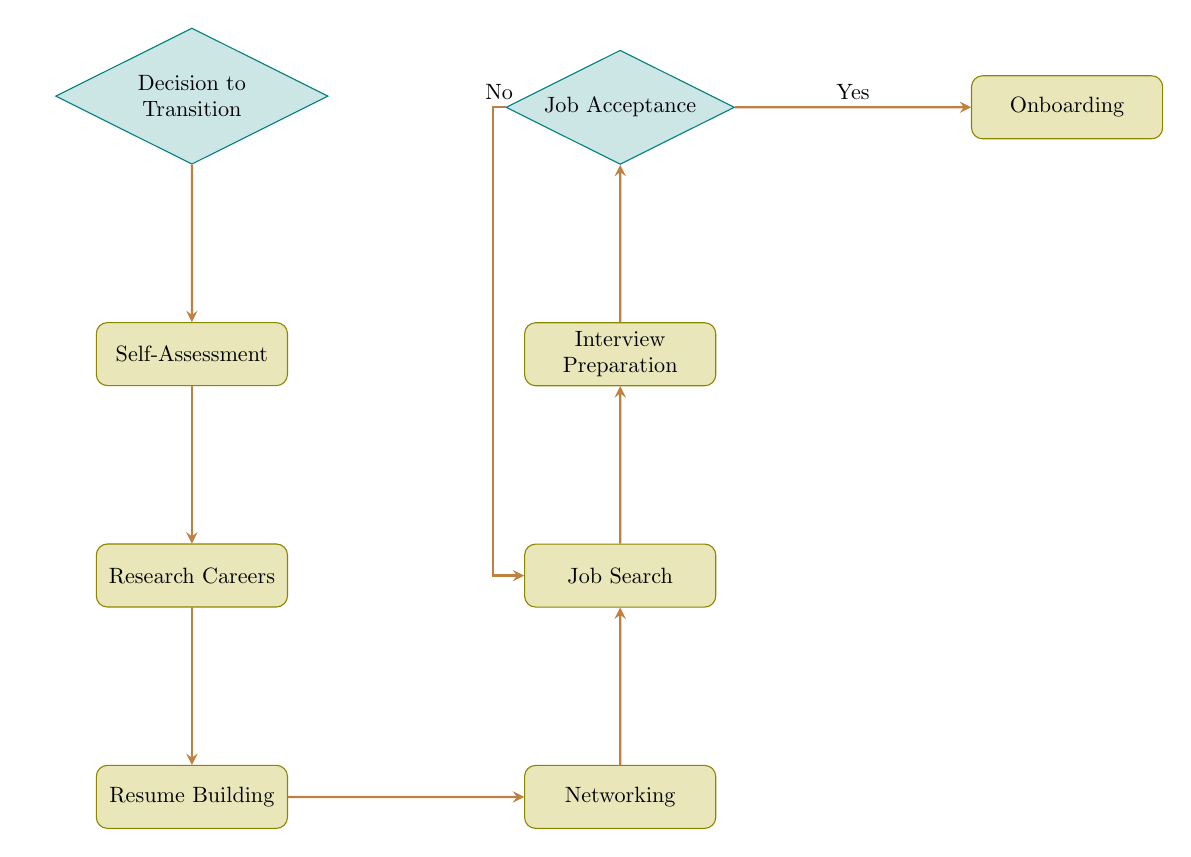What is the first step in transitioning from military to civilian career? The diagram starts with the node labeled "Decision to Transition," indicating that the first step is to decide to transition.
Answer: Decision to Transition How many process nodes are in the diagram? The process nodes are: Self-Assessment, Research Careers, Resume Building, Networking, Job Search, Interview Preparation, and Onboarding. Counting these gives a total of seven process nodes.
Answer: Seven What happens if the outcome of Job Acceptance is "No"? According to the diagram, if the answer to Job Acceptance is "No," it returns to the Job Search process, indicating that further job applications or efforts are needed.
Answer: Job Search What is the relationship between Resume Building and Networking? The flow indicates that one must complete the Resume Building process before moving on to the Networking process, demonstrating a sequential relationship.
Answer: Sequential Which node comes after Interview Preparation? Following the flow from Interview Preparation, the next node is Job Acceptance, indicating that interview preparation leads directly to the decision of accepting a job offer.
Answer: Job Acceptance What connects the Job Acceptance decision to Onboarding? The connection from Job Acceptance to Onboarding is conditional; it states "Yes," indicating that if one accepts the job offer, the next step is onboarding into the new job.
Answer: Yes How does one move from Self-Assessment to Research Careers? The flow from Self-Assessment to Research Careers is direct, meaning once a self-assessment is completed, the next step is to research potential careers.
Answer: Direct Which node is at the far right of the flow chart? The node located at the far right in the diagram is "Onboarding," indicating that it is the final process after accepting a job offer.
Answer: Onboarding 